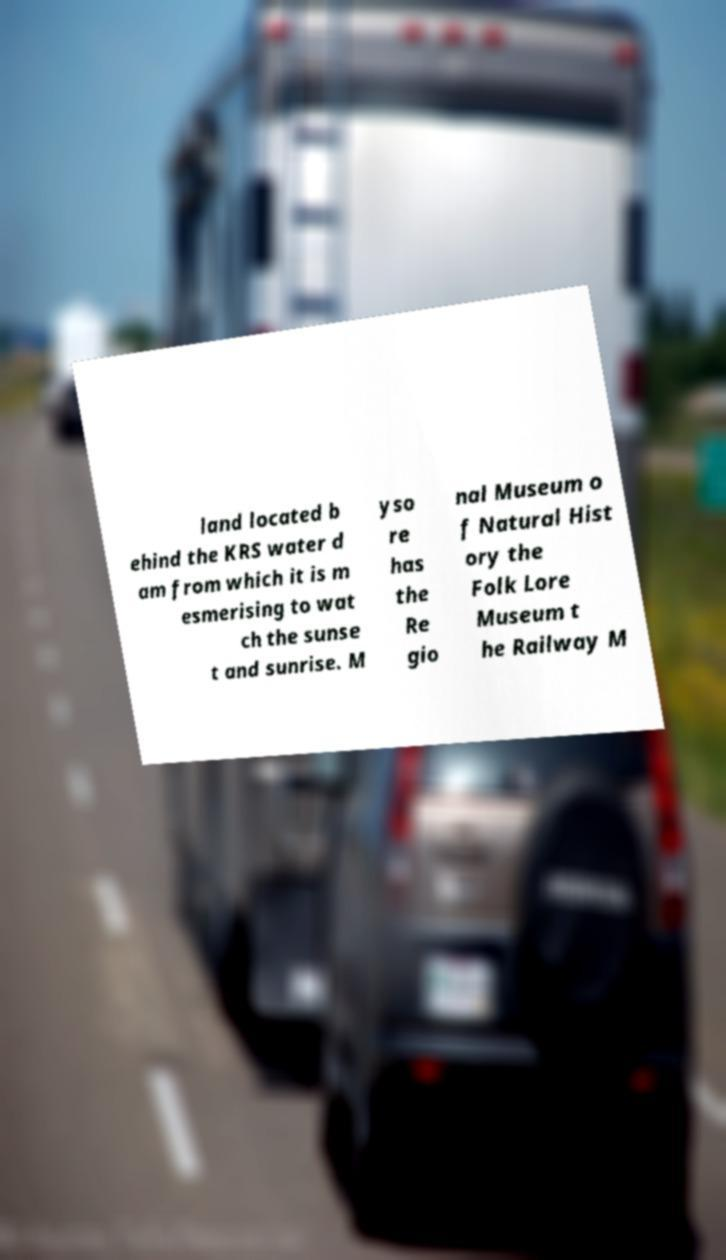There's text embedded in this image that I need extracted. Can you transcribe it verbatim? land located b ehind the KRS water d am from which it is m esmerising to wat ch the sunse t and sunrise. M yso re has the Re gio nal Museum o f Natural Hist ory the Folk Lore Museum t he Railway M 